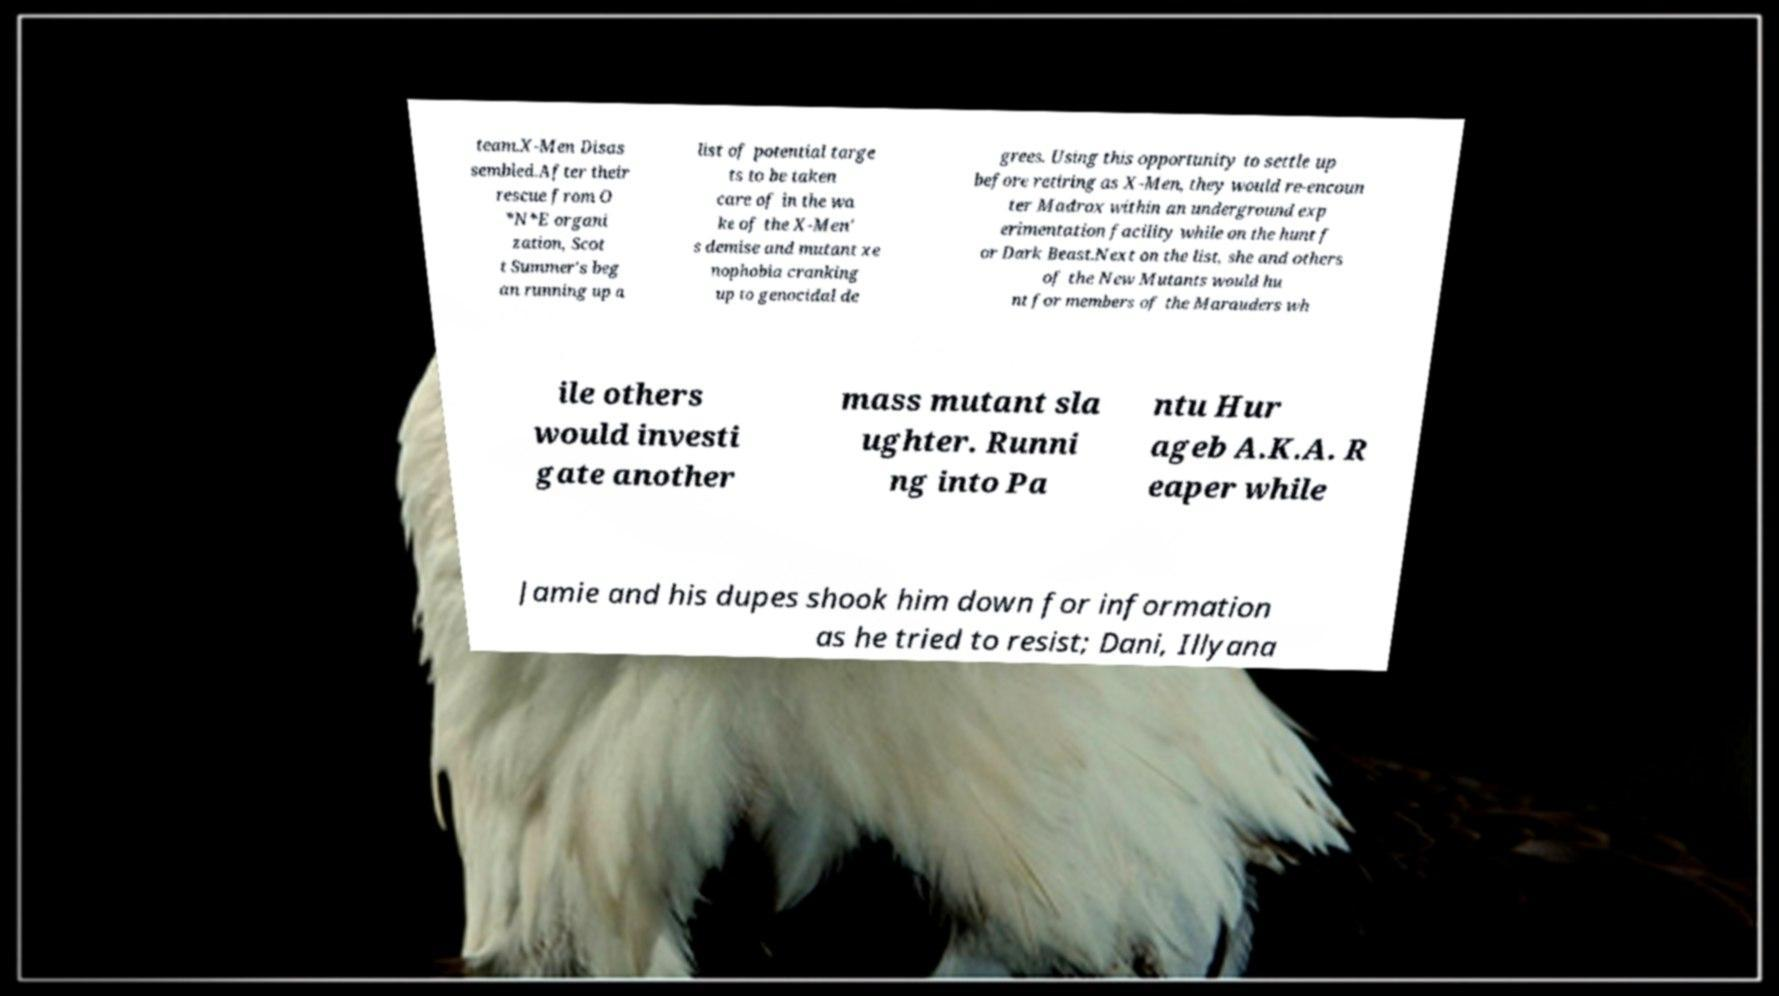Could you assist in decoding the text presented in this image and type it out clearly? team.X-Men Disas sembled.After their rescue from O *N*E organi zation, Scot t Summer's beg an running up a list of potential targe ts to be taken care of in the wa ke of the X-Men' s demise and mutant xe nophobia cranking up to genocidal de grees. Using this opportunity to settle up before retiring as X-Men, they would re-encoun ter Madrox within an underground exp erimentation facility while on the hunt f or Dark Beast.Next on the list, she and others of the New Mutants would hu nt for members of the Marauders wh ile others would investi gate another mass mutant sla ughter. Runni ng into Pa ntu Hur ageb A.K.A. R eaper while Jamie and his dupes shook him down for information as he tried to resist; Dani, Illyana 